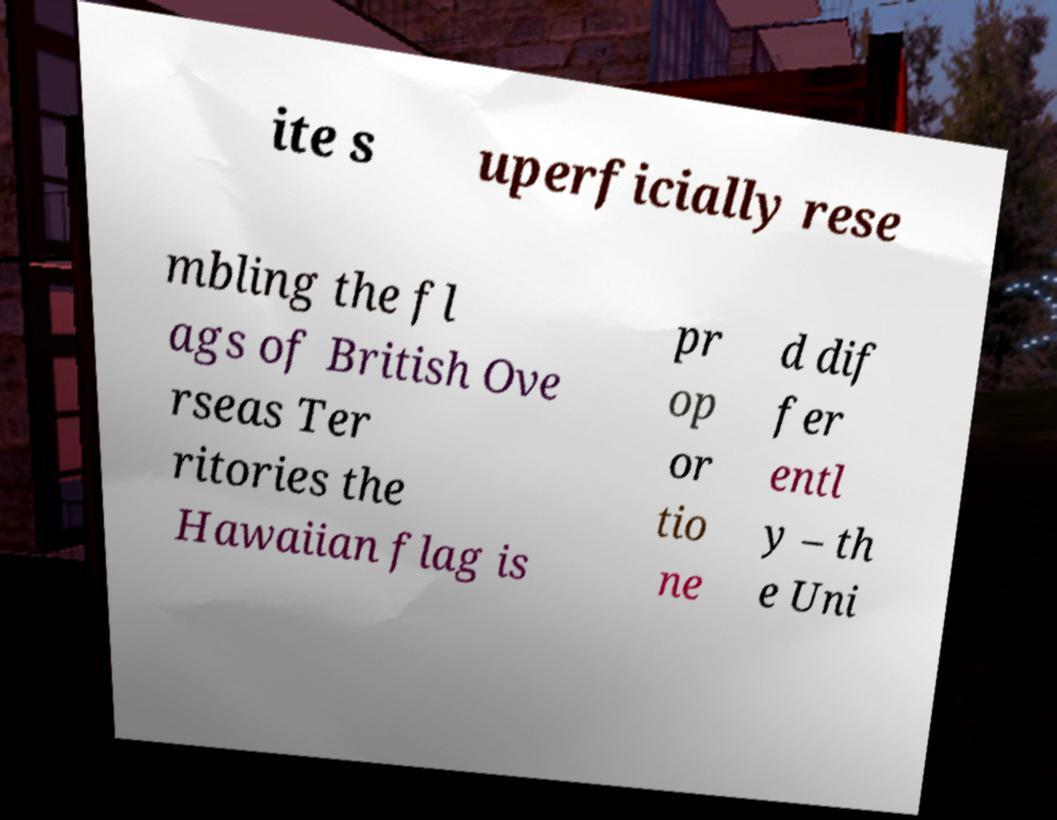Could you extract and type out the text from this image? ite s uperficially rese mbling the fl ags of British Ove rseas Ter ritories the Hawaiian flag is pr op or tio ne d dif fer entl y – th e Uni 